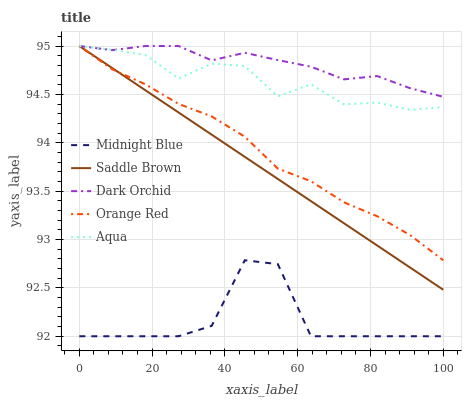Does Midnight Blue have the minimum area under the curve?
Answer yes or no. Yes. Does Dark Orchid have the maximum area under the curve?
Answer yes or no. Yes. Does Aqua have the minimum area under the curve?
Answer yes or no. No. Does Aqua have the maximum area under the curve?
Answer yes or no. No. Is Saddle Brown the smoothest?
Answer yes or no. Yes. Is Midnight Blue the roughest?
Answer yes or no. Yes. Is Aqua the smoothest?
Answer yes or no. No. Is Aqua the roughest?
Answer yes or no. No. Does Midnight Blue have the lowest value?
Answer yes or no. Yes. Does Aqua have the lowest value?
Answer yes or no. No. Does Saddle Brown have the highest value?
Answer yes or no. Yes. Does Midnight Blue have the highest value?
Answer yes or no. No. Is Midnight Blue less than Saddle Brown?
Answer yes or no. Yes. Is Orange Red greater than Midnight Blue?
Answer yes or no. Yes. Does Saddle Brown intersect Orange Red?
Answer yes or no. Yes. Is Saddle Brown less than Orange Red?
Answer yes or no. No. Is Saddle Brown greater than Orange Red?
Answer yes or no. No. Does Midnight Blue intersect Saddle Brown?
Answer yes or no. No. 